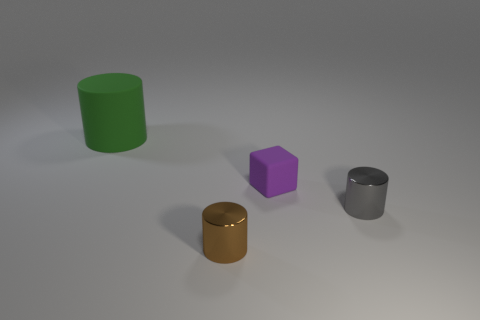Subtract all tiny cylinders. How many cylinders are left? 1 Add 2 rubber cylinders. How many objects exist? 6 Subtract all cubes. How many objects are left? 3 Subtract 0 gray balls. How many objects are left? 4 Subtract all yellow cylinders. Subtract all blue cubes. How many cylinders are left? 3 Subtract all purple matte things. Subtract all large cyan metal cylinders. How many objects are left? 3 Add 2 small brown metal things. How many small brown metal things are left? 3 Add 2 small brown things. How many small brown things exist? 3 